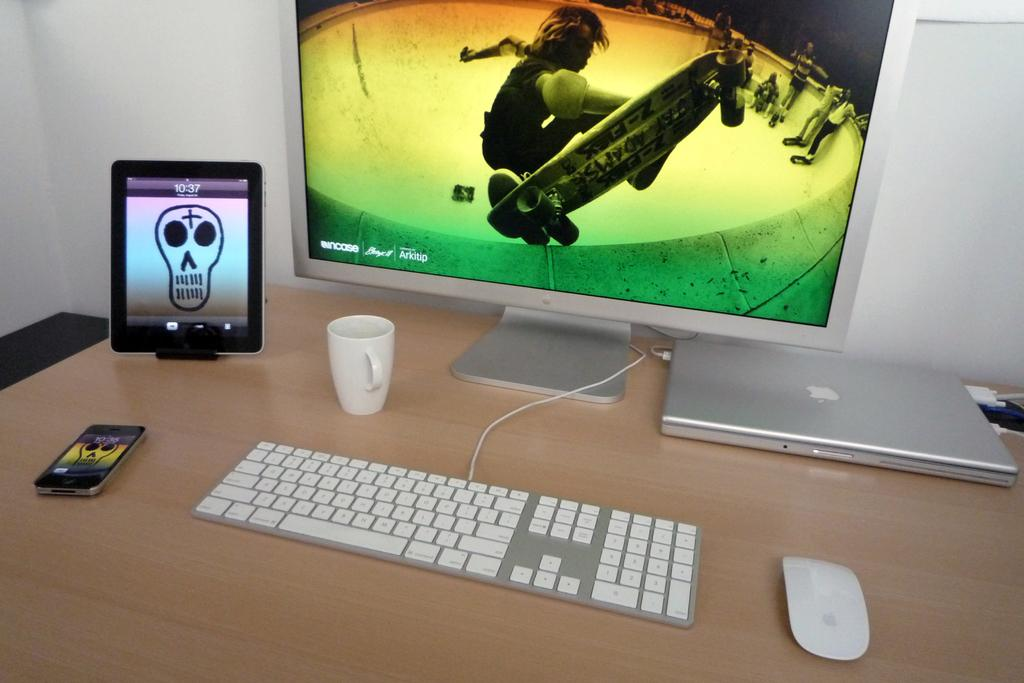<image>
Write a terse but informative summary of the picture. Various Apple devices sit together on a desk with a display screen that says Incase 